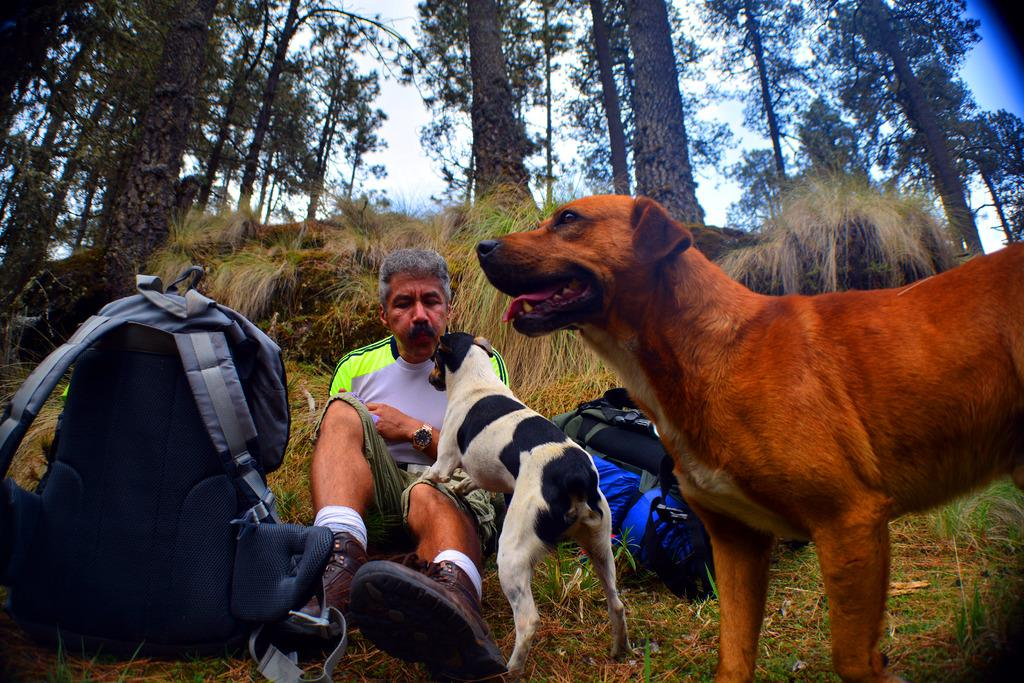How many dogs are present in the image? There are two dogs in the image. What is the man in the image doing with one of the dogs? The man is playing with one of the dogs. What can be seen in the background of the image? There are trees visible in the background. What object can be seen in the image besides the dogs and the man? There is a bag in the image. What type of engine can be seen powering the clam in the image? There is no engine or clam present in the image. 